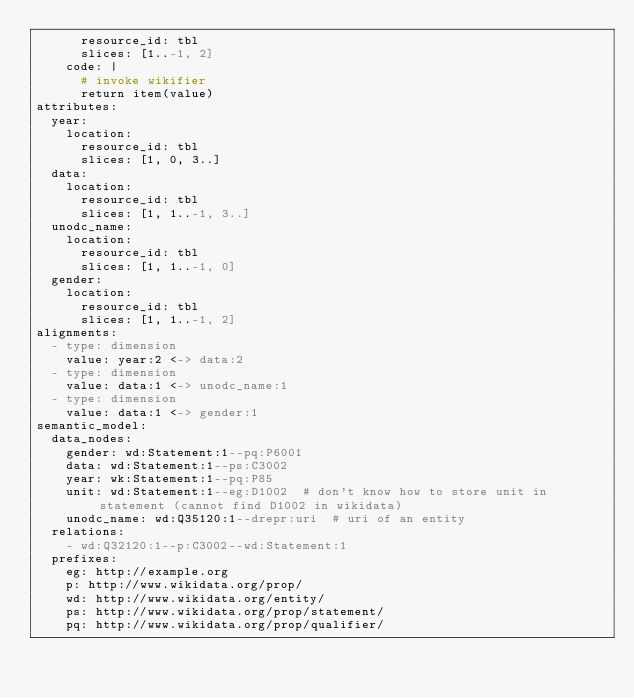Convert code to text. <code><loc_0><loc_0><loc_500><loc_500><_YAML_>      resource_id: tbl
      slices: [1..-1, 2]
    code: |
      # invoke wikifier
      return item(value)
attributes:
  year:
    location:
      resource_id: tbl
      slices: [1, 0, 3..]
  data:
    location:
      resource_id: tbl
      slices: [1, 1..-1, 3..]
  unodc_name:
    location:
      resource_id: tbl
      slices: [1, 1..-1, 0]
  gender:
    location:
      resource_id: tbl
      slices: [1, 1..-1, 2]
alignments:
  - type: dimension
    value: year:2 <-> data:2
  - type: dimension
    value: data:1 <-> unodc_name:1
  - type: dimension
    value: data:1 <-> gender:1
semantic_model:
  data_nodes:
    gender: wd:Statement:1--pq:P6001
    data: wd:Statement:1--ps:C3002
    year: wk:Statement:1--pq:P85
    unit: wd:Statement:1--eg:D1002  # don't know how to store unit in statement (cannot find D1002 in wikidata)
    unodc_name: wd:Q35120:1--drepr:uri  # uri of an entity
  relations:
    - wd:Q32120:1--p:C3002--wd:Statement:1
  prefixes:
    eg: http://example.org
    p: http://www.wikidata.org/prop/
    wd: http://www.wikidata.org/entity/
    ps: http://www.wikidata.org/prop/statement/
    pq: http://www.wikidata.org/prop/qualifier/</code> 